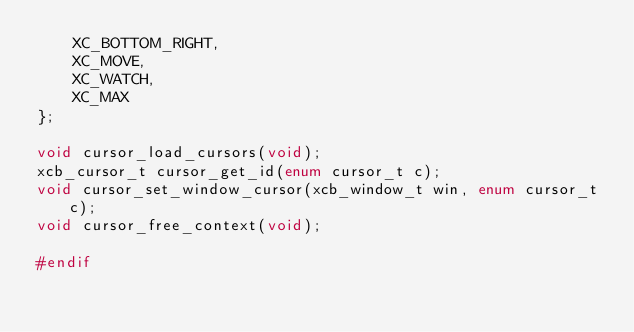<code> <loc_0><loc_0><loc_500><loc_500><_C_>    XC_BOTTOM_RIGHT,
    XC_MOVE,
    XC_WATCH,
    XC_MAX
};

void cursor_load_cursors(void);
xcb_cursor_t cursor_get_id(enum cursor_t c);
void cursor_set_window_cursor(xcb_window_t win, enum cursor_t c);
void cursor_free_context(void);

#endif
</code> 